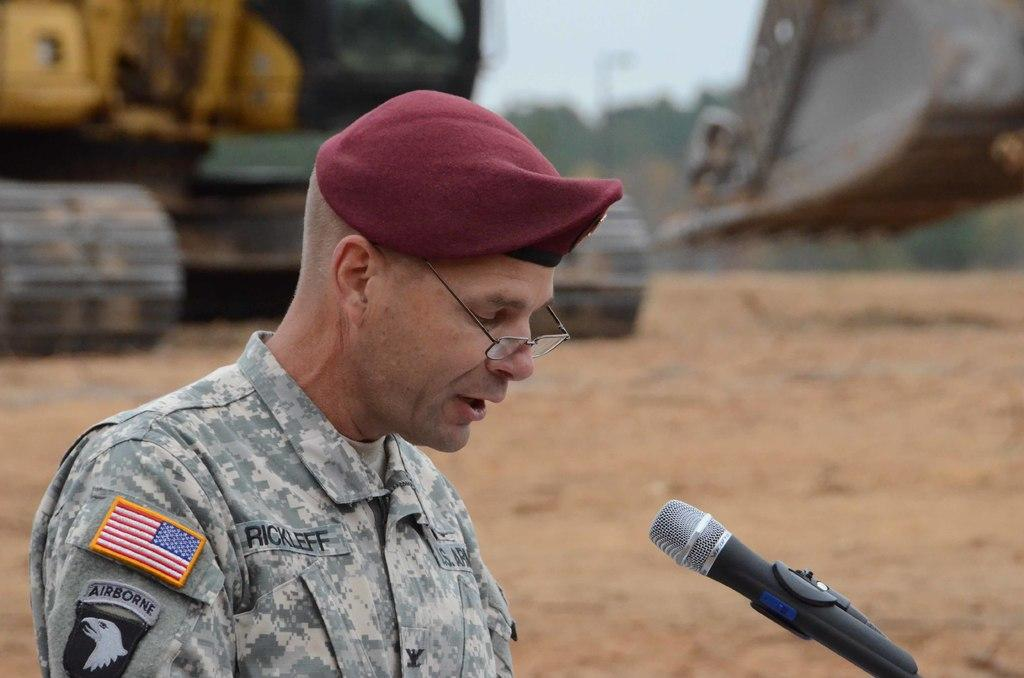Who is present in the image? There is a person in the image. What is the person wearing? The person is wearing a uniform. What is the person holding in the image? The person is holding a mic. What can be seen in the background of the image? There is a crane on the ground in the background of the image. Where is the basin located in the image? There is no basin present in the image. What type of icicle can be seen hanging from the crane in the image? There is no icicle present in the image; it is a crane on the ground. 